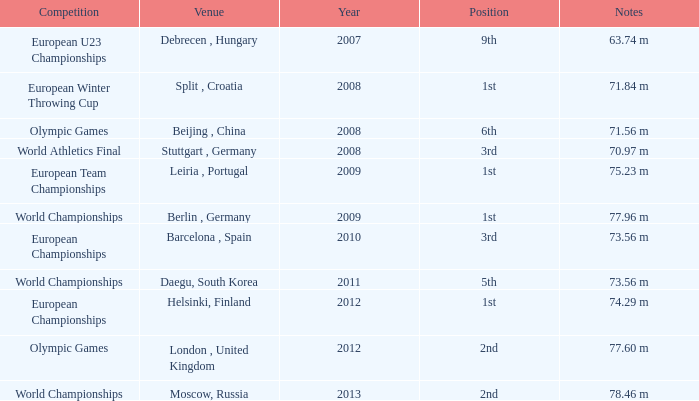Write the full table. {'header': ['Competition', 'Venue', 'Year', 'Position', 'Notes'], 'rows': [['European U23 Championships', 'Debrecen , Hungary', '2007', '9th', '63.74 m'], ['European Winter Throwing Cup', 'Split , Croatia', '2008', '1st', '71.84 m'], ['Olympic Games', 'Beijing , China', '2008', '6th', '71.56 m'], ['World Athletics Final', 'Stuttgart , Germany', '2008', '3rd', '70.97 m'], ['European Team Championships', 'Leiria , Portugal', '2009', '1st', '75.23 m'], ['World Championships', 'Berlin , Germany', '2009', '1st', '77.96 m'], ['European Championships', 'Barcelona , Spain', '2010', '3rd', '73.56 m'], ['World Championships', 'Daegu, South Korea', '2011', '5th', '73.56 m'], ['European Championships', 'Helsinki, Finland', '2012', '1st', '74.29 m'], ['Olympic Games', 'London , United Kingdom', '2012', '2nd', '77.60 m'], ['World Championships', 'Moscow, Russia', '2013', '2nd', '78.46 m']]} Which Year has a Position of 9th? 2007.0. 